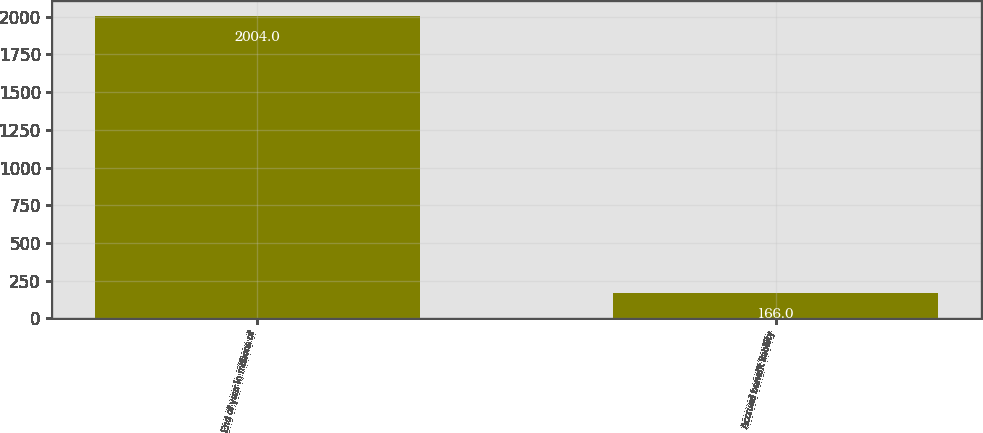Convert chart to OTSL. <chart><loc_0><loc_0><loc_500><loc_500><bar_chart><fcel>End of year in millions of<fcel>Accrued benefit liability<nl><fcel>2004<fcel>166<nl></chart> 